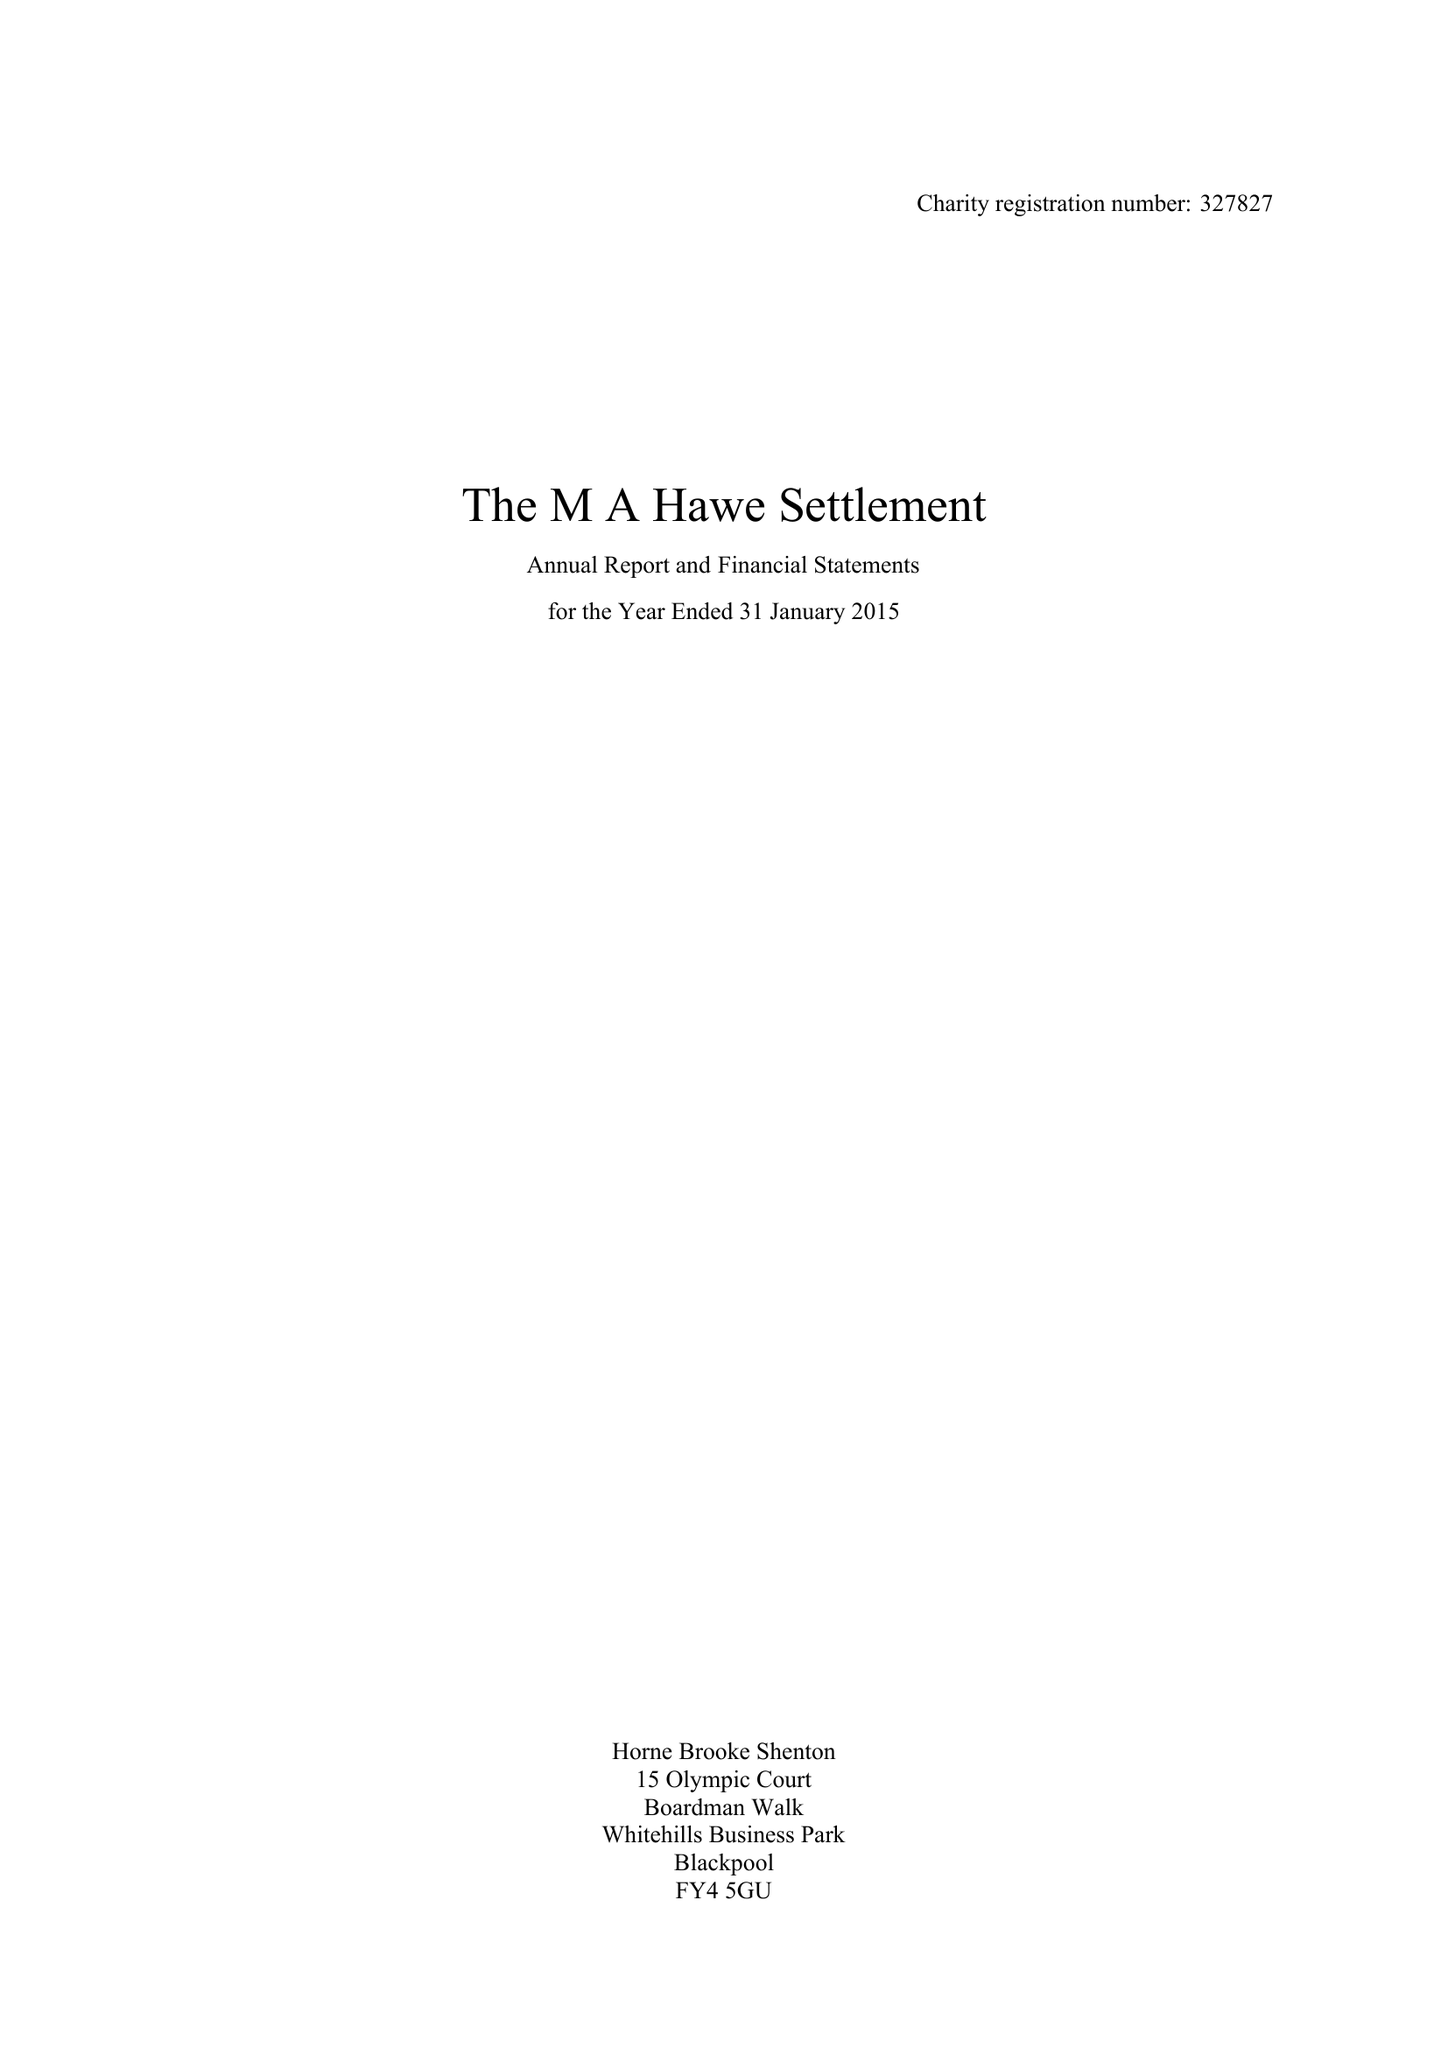What is the value for the address__street_line?
Answer the question using a single word or phrase. 94 PARK VIEW ROAD 